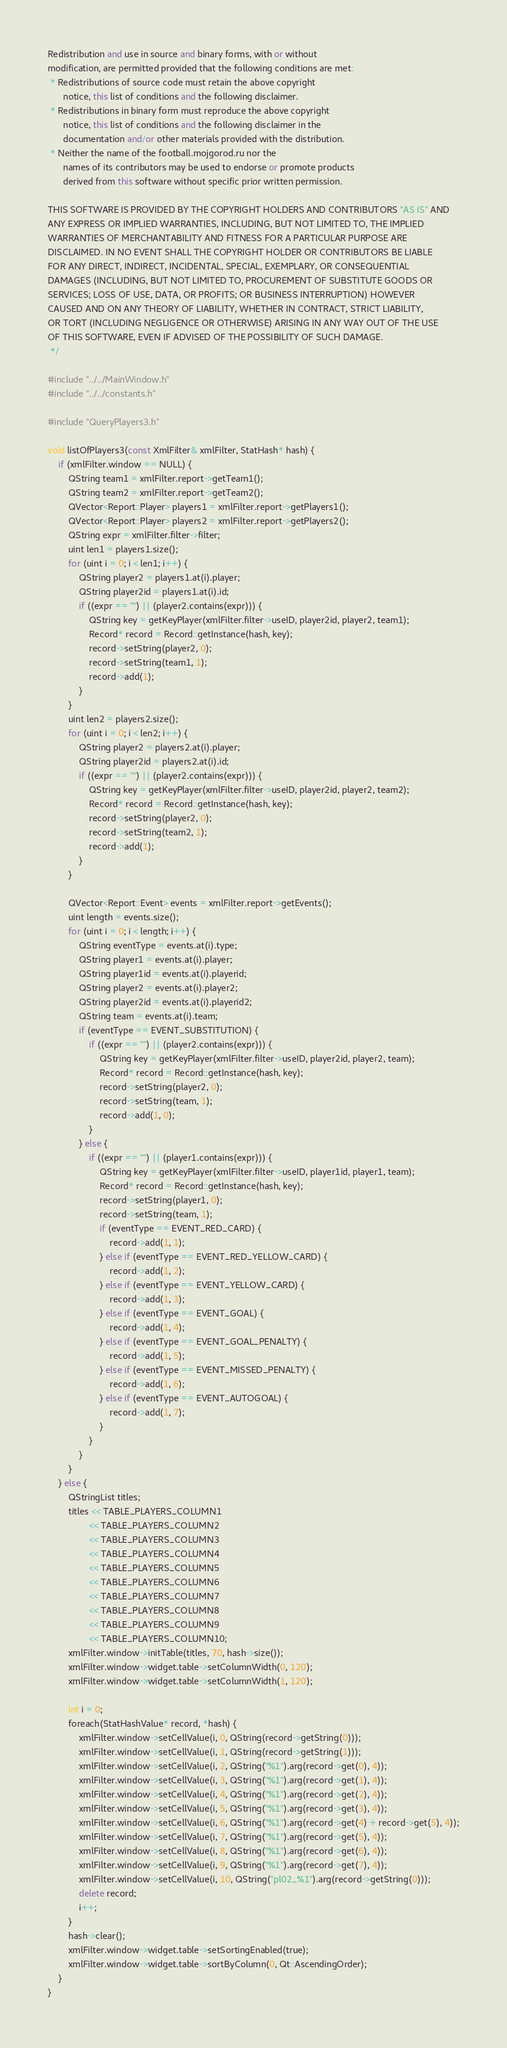<code> <loc_0><loc_0><loc_500><loc_500><_C++_>Redistribution and use in source and binary forms, with or without
modification, are permitted provided that the following conditions are met:
 * Redistributions of source code must retain the above copyright
      notice, this list of conditions and the following disclaimer.
 * Redistributions in binary form must reproduce the above copyright
      notice, this list of conditions and the following disclaimer in the
      documentation and/or other materials provided with the distribution.
 * Neither the name of the football.mojgorod.ru nor the
      names of its contributors may be used to endorse or promote products
      derived from this software without specific prior written permission.

THIS SOFTWARE IS PROVIDED BY THE COPYRIGHT HOLDERS AND CONTRIBUTORS "AS IS" AND
ANY EXPRESS OR IMPLIED WARRANTIES, INCLUDING, BUT NOT LIMITED TO, THE IMPLIED
WARRANTIES OF MERCHANTABILITY AND FITNESS FOR A PARTICULAR PURPOSE ARE
DISCLAIMED. IN NO EVENT SHALL THE COPYRIGHT HOLDER OR CONTRIBUTORS BE LIABLE
FOR ANY DIRECT, INDIRECT, INCIDENTAL, SPECIAL, EXEMPLARY, OR CONSEQUENTIAL
DAMAGES (INCLUDING, BUT NOT LIMITED TO, PROCUREMENT OF SUBSTITUTE GOODS OR
SERVICES; LOSS OF USE, DATA, OR PROFITS; OR BUSINESS INTERRUPTION) HOWEVER
CAUSED AND ON ANY THEORY OF LIABILITY, WHETHER IN CONTRACT, STRICT LIABILITY,
OR TORT (INCLUDING NEGLIGENCE OR OTHERWISE) ARISING IN ANY WAY OUT OF THE USE
OF THIS SOFTWARE, EVEN IF ADVISED OF THE POSSIBILITY OF SUCH DAMAGE.
 */

#include "../../MainWindow.h"
#include "../../constants.h"

#include "QueryPlayers3.h"

void listOfPlayers3(const XmlFilter& xmlFilter, StatHash* hash) {
    if (xmlFilter.window == NULL) {
        QString team1 = xmlFilter.report->getTeam1();
        QString team2 = xmlFilter.report->getTeam2();
        QVector<Report::Player> players1 = xmlFilter.report->getPlayers1();
        QVector<Report::Player> players2 = xmlFilter.report->getPlayers2();
        QString expr = xmlFilter.filter->filter;
        uint len1 = players1.size();
        for (uint i = 0; i < len1; i++) {
            QString player2 = players1.at(i).player;
            QString player2id = players1.at(i).id;
            if ((expr == "") || (player2.contains(expr))) {
                QString key = getKeyPlayer(xmlFilter.filter->useID, player2id, player2, team1);
                Record* record = Record::getInstance(hash, key);
                record->setString(player2, 0);
                record->setString(team1, 1);
                record->add(1);
            }
        }
        uint len2 = players2.size();
        for (uint i = 0; i < len2; i++) {
            QString player2 = players2.at(i).player;
            QString player2id = players2.at(i).id;
            if ((expr == "") || (player2.contains(expr))) {
                QString key = getKeyPlayer(xmlFilter.filter->useID, player2id, player2, team2);
                Record* record = Record::getInstance(hash, key);
                record->setString(player2, 0);
                record->setString(team2, 1);
                record->add(1);
            }
        }

        QVector<Report::Event> events = xmlFilter.report->getEvents();
        uint length = events.size();
        for (uint i = 0; i < length; i++) {
            QString eventType = events.at(i).type;
            QString player1 = events.at(i).player;
            QString player1id = events.at(i).playerid;
            QString player2 = events.at(i).player2;
            QString player2id = events.at(i).playerid2;
            QString team = events.at(i).team;
            if (eventType == EVENT_SUBSTITUTION) {
                if ((expr == "") || (player2.contains(expr))) {
                    QString key = getKeyPlayer(xmlFilter.filter->useID, player2id, player2, team);
                    Record* record = Record::getInstance(hash, key);
                    record->setString(player2, 0);
                    record->setString(team, 1);
                    record->add(1, 0);
                }
            } else {
                if ((expr == "") || (player1.contains(expr))) {
                    QString key = getKeyPlayer(xmlFilter.filter->useID, player1id, player1, team);
                    Record* record = Record::getInstance(hash, key);
                    record->setString(player1, 0);
                    record->setString(team, 1);
                    if (eventType == EVENT_RED_CARD) {
                        record->add(1, 1);
                    } else if (eventType == EVENT_RED_YELLOW_CARD) {
                        record->add(1, 2);
                    } else if (eventType == EVENT_YELLOW_CARD) {
                        record->add(1, 3);
                    } else if (eventType == EVENT_GOAL) {
                        record->add(1, 4);
                    } else if (eventType == EVENT_GOAL_PENALTY) {
                        record->add(1, 5);
                    } else if (eventType == EVENT_MISSED_PENALTY) {
                        record->add(1, 6);
                    } else if (eventType == EVENT_AUTOGOAL) {
                        record->add(1, 7);
                    }
                }
            }
        }
    } else {
        QStringList titles;
        titles << TABLE_PLAYERS_COLUMN1
                << TABLE_PLAYERS_COLUMN2
                << TABLE_PLAYERS_COLUMN3
                << TABLE_PLAYERS_COLUMN4
                << TABLE_PLAYERS_COLUMN5
                << TABLE_PLAYERS_COLUMN6
                << TABLE_PLAYERS_COLUMN7
                << TABLE_PLAYERS_COLUMN8
                << TABLE_PLAYERS_COLUMN9
                << TABLE_PLAYERS_COLUMN10;
        xmlFilter.window->initTable(titles, 70, hash->size());
        xmlFilter.window->widget.table->setColumnWidth(0, 120);
        xmlFilter.window->widget.table->setColumnWidth(1, 120);

        int i = 0;
        foreach(StatHashValue* record, *hash) {
            xmlFilter.window->setCellValue(i, 0, QString(record->getString(0)));
            xmlFilter.window->setCellValue(i, 1, QString(record->getString(1)));
            xmlFilter.window->setCellValue(i, 2, QString("%1").arg(record->get(0), 4));
            xmlFilter.window->setCellValue(i, 3, QString("%1").arg(record->get(1), 4));
            xmlFilter.window->setCellValue(i, 4, QString("%1").arg(record->get(2), 4));
            xmlFilter.window->setCellValue(i, 5, QString("%1").arg(record->get(3), 4));
            xmlFilter.window->setCellValue(i, 6, QString("%1").arg(record->get(4) + record->get(5), 4));
            xmlFilter.window->setCellValue(i, 7, QString("%1").arg(record->get(5), 4));
            xmlFilter.window->setCellValue(i, 8, QString("%1").arg(record->get(6), 4));
            xmlFilter.window->setCellValue(i, 9, QString("%1").arg(record->get(7), 4));
            xmlFilter.window->setCellValue(i, 10, QString("pl02_%1").arg(record->getString(0)));
            delete record;
            i++;
        }
        hash->clear();
        xmlFilter.window->widget.table->setSortingEnabled(true);
        xmlFilter.window->widget.table->sortByColumn(0, Qt::AscendingOrder);
    }
}
</code> 